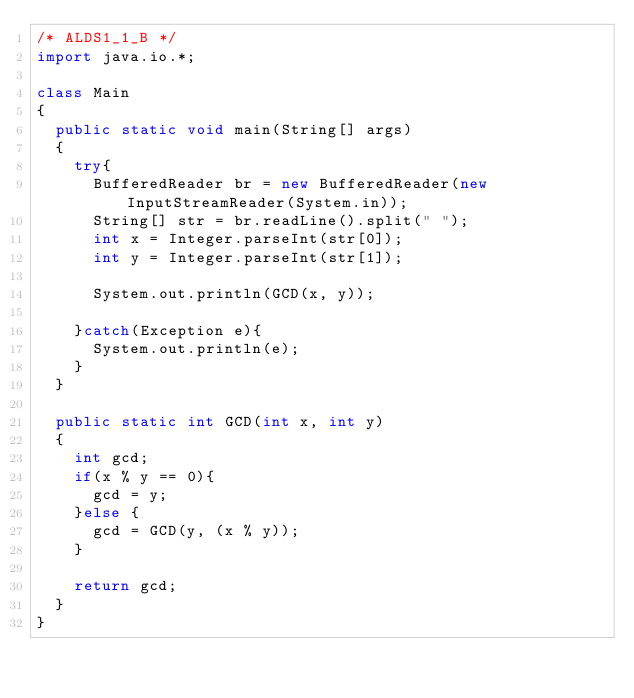Convert code to text. <code><loc_0><loc_0><loc_500><loc_500><_Java_>/* ALDS1_1_B */
import java.io.*;

class Main
{
  public static void main(String[] args)
  {
    try{
      BufferedReader br = new BufferedReader(new InputStreamReader(System.in));
      String[] str = br.readLine().split(" ");
      int x = Integer.parseInt(str[0]);
      int y = Integer.parseInt(str[1]);

      System.out.println(GCD(x, y));

    }catch(Exception e){
      System.out.println(e);
    }
  }

  public static int GCD(int x, int y)
  {
    int gcd;
    if(x % y == 0){
      gcd = y;
    }else {
      gcd = GCD(y, (x % y));
    }

    return gcd;
  }
}</code> 